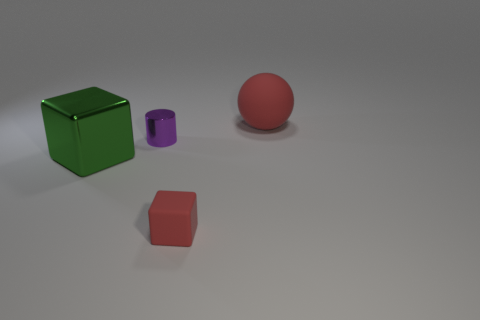Does the metal cube have the same size as the purple object?
Make the answer very short. No. What color is the matte cube that is the same size as the purple thing?
Give a very brief answer. Red. There is a shiny cube; is it the same size as the thing that is in front of the large metallic cube?
Offer a very short reply. No. How many tiny cubes are the same color as the sphere?
Your answer should be very brief. 1. How many things are small purple shiny cylinders or things that are to the right of the small rubber block?
Provide a short and direct response. 2. Does the red matte thing in front of the big sphere have the same size as the metal object that is on the right side of the large green metallic block?
Provide a succinct answer. Yes. Are there any small gray cylinders that have the same material as the green thing?
Keep it short and to the point. No. What is the shape of the tiny red thing?
Your answer should be very brief. Cube. What is the shape of the red rubber object in front of the red thing that is on the right side of the matte cube?
Your response must be concise. Cube. What number of other objects are the same shape as the large red matte object?
Provide a short and direct response. 0. 